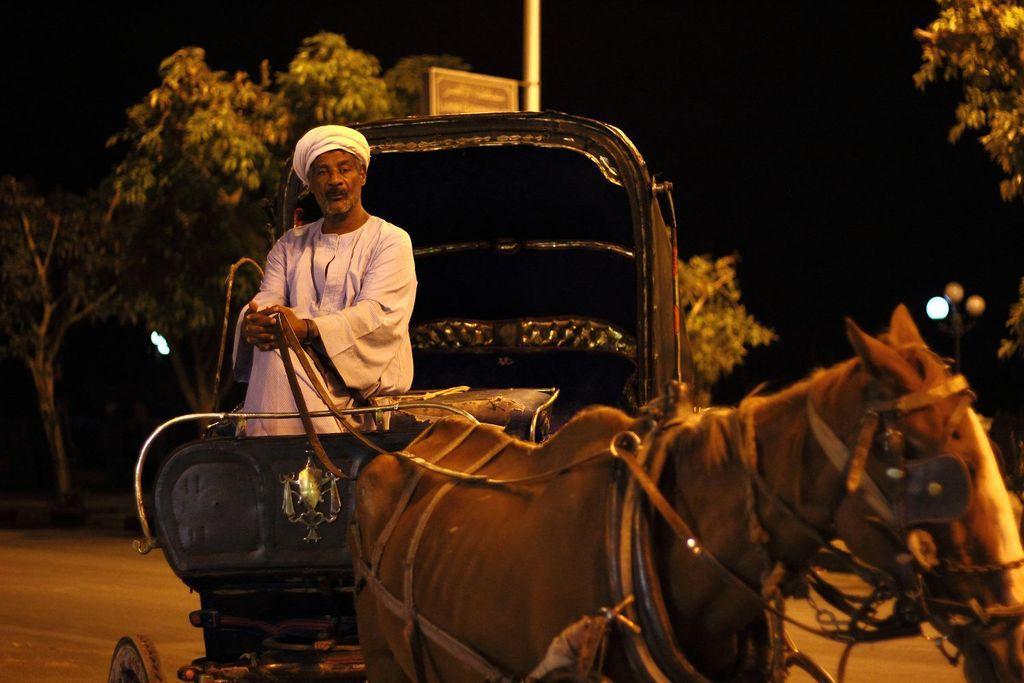Please provide a concise description of this image. In this image there is a horse and a cart. A man is riding the horse. He is wearing a white colored dress. Behind him there is a tree and its the night time 